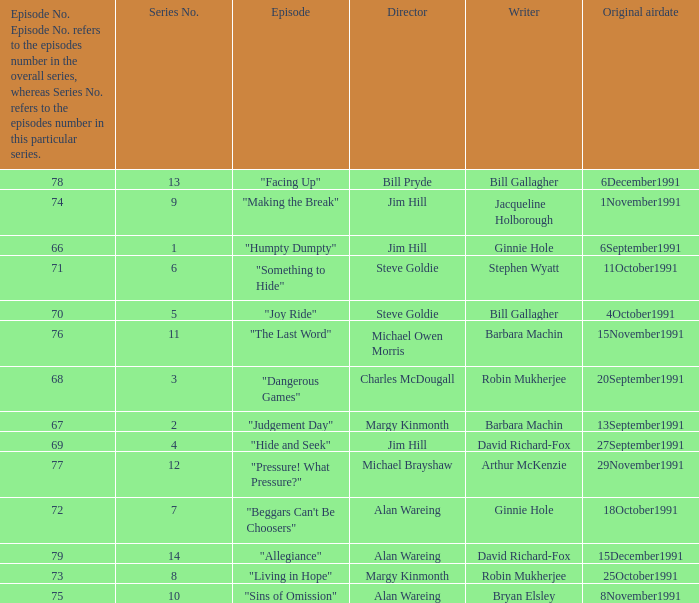Name the least series number for episode number being 78 13.0. 